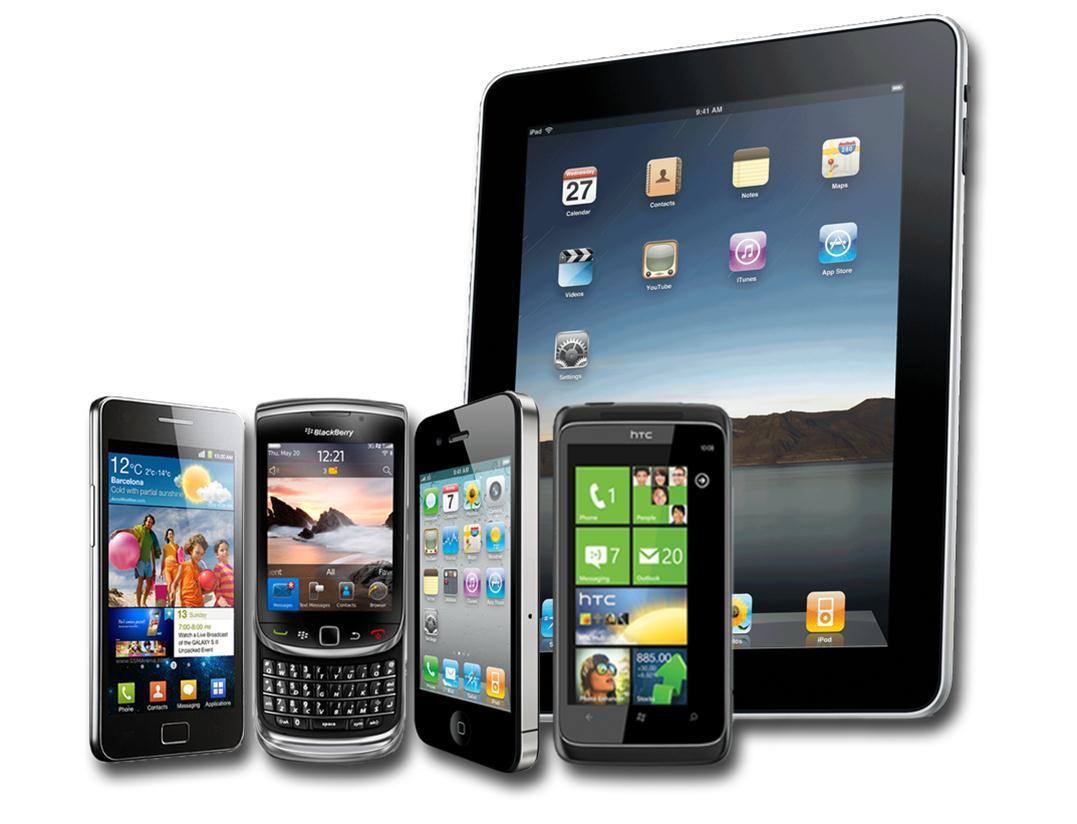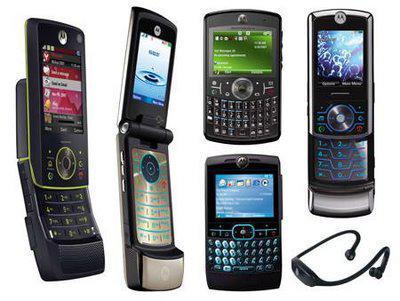The first image is the image on the left, the second image is the image on the right. Examine the images to the left and right. Is the description "One image contains multiple devices with none overlapping, and the other image contains multiple devices with at least some overlapping." accurate? Answer yes or no. Yes. 